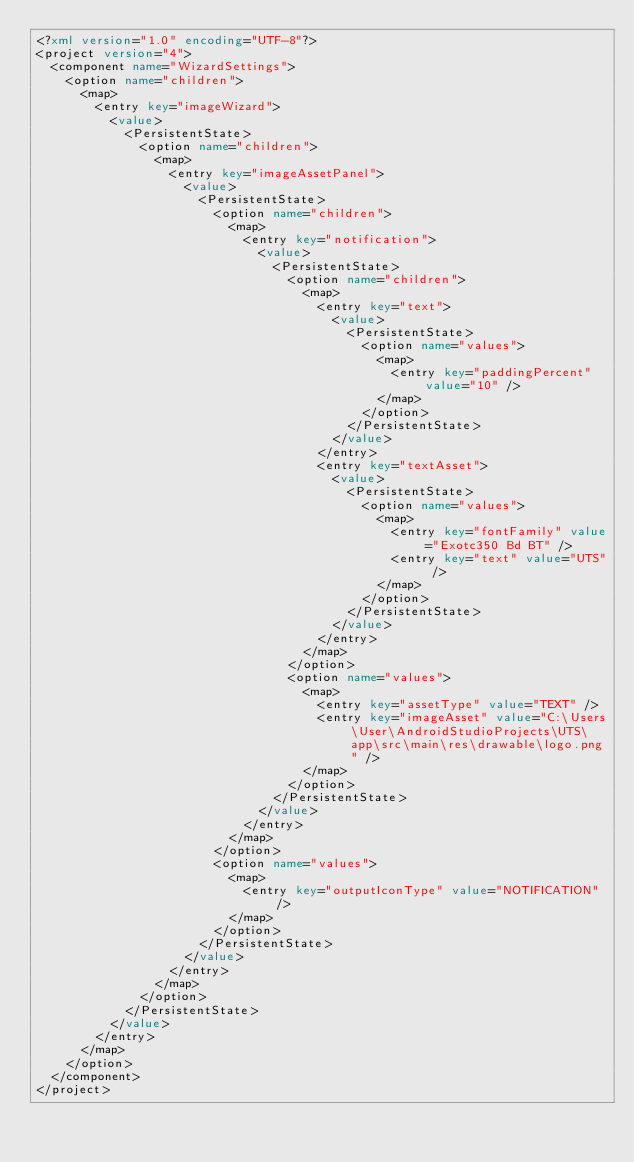Convert code to text. <code><loc_0><loc_0><loc_500><loc_500><_XML_><?xml version="1.0" encoding="UTF-8"?>
<project version="4">
  <component name="WizardSettings">
    <option name="children">
      <map>
        <entry key="imageWizard">
          <value>
            <PersistentState>
              <option name="children">
                <map>
                  <entry key="imageAssetPanel">
                    <value>
                      <PersistentState>
                        <option name="children">
                          <map>
                            <entry key="notification">
                              <value>
                                <PersistentState>
                                  <option name="children">
                                    <map>
                                      <entry key="text">
                                        <value>
                                          <PersistentState>
                                            <option name="values">
                                              <map>
                                                <entry key="paddingPercent" value="10" />
                                              </map>
                                            </option>
                                          </PersistentState>
                                        </value>
                                      </entry>
                                      <entry key="textAsset">
                                        <value>
                                          <PersistentState>
                                            <option name="values">
                                              <map>
                                                <entry key="fontFamily" value="Exotc350 Bd BT" />
                                                <entry key="text" value="UTS" />
                                              </map>
                                            </option>
                                          </PersistentState>
                                        </value>
                                      </entry>
                                    </map>
                                  </option>
                                  <option name="values">
                                    <map>
                                      <entry key="assetType" value="TEXT" />
                                      <entry key="imageAsset" value="C:\Users\User\AndroidStudioProjects\UTS\app\src\main\res\drawable\logo.png" />
                                    </map>
                                  </option>
                                </PersistentState>
                              </value>
                            </entry>
                          </map>
                        </option>
                        <option name="values">
                          <map>
                            <entry key="outputIconType" value="NOTIFICATION" />
                          </map>
                        </option>
                      </PersistentState>
                    </value>
                  </entry>
                </map>
              </option>
            </PersistentState>
          </value>
        </entry>
      </map>
    </option>
  </component>
</project></code> 